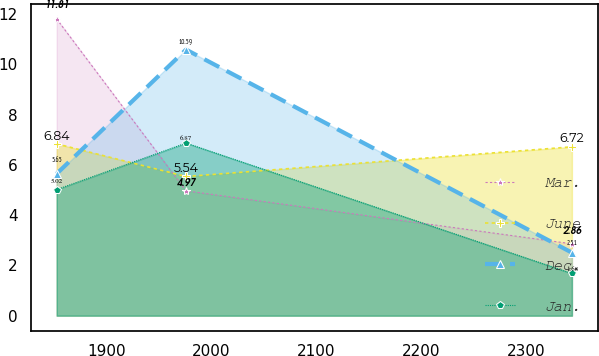Convert chart to OTSL. <chart><loc_0><loc_0><loc_500><loc_500><line_chart><ecel><fcel>Mar.<fcel>June<fcel>Dec.<fcel>Jan.<nl><fcel>1852.74<fcel>11.81<fcel>6.84<fcel>5.65<fcel>5.02<nl><fcel>1976<fcel>4.97<fcel>5.54<fcel>10.59<fcel>6.87<nl><fcel>2343.65<fcel>2.86<fcel>6.72<fcel>2.51<fcel>1.68<nl></chart> 